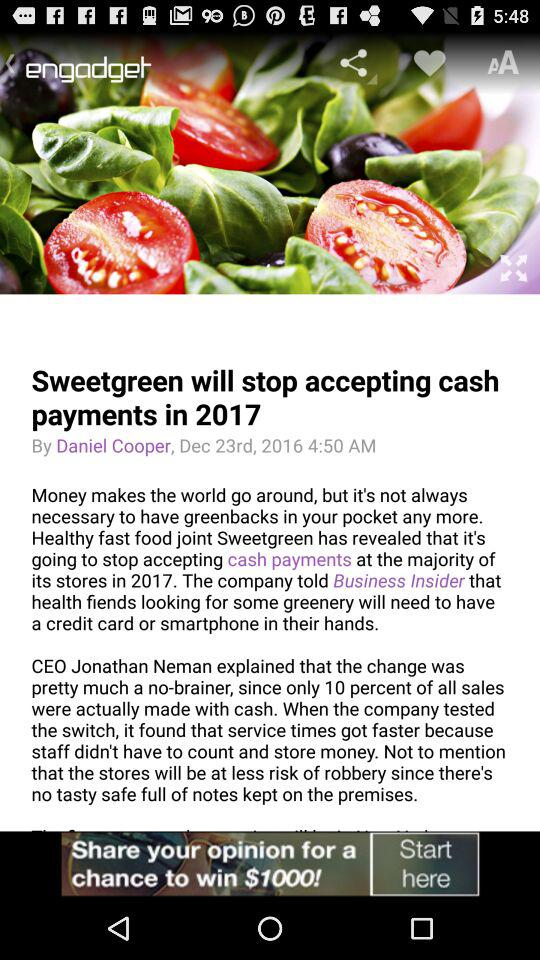What is the posting date of an article? The date of posting is December 23, 2016. 